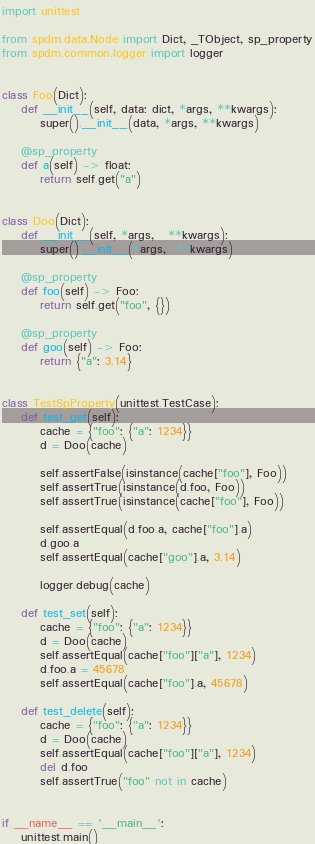<code> <loc_0><loc_0><loc_500><loc_500><_Python_>import unittest

from spdm.data.Node import Dict, _TObject, sp_property
from spdm.common.logger import logger


class Foo(Dict):
    def __init__(self, data: dict, *args, **kwargs):
        super().__init__(data, *args, **kwargs)

    @sp_property
    def a(self) -> float:
        return self.get("a")


class Doo(Dict):
    def __init__(self, *args,   **kwargs):
        super().__init__(*args,  **kwargs)

    @sp_property
    def foo(self) -> Foo:
        return self.get("foo", {})

    @sp_property
    def goo(self) -> Foo:
        return {"a": 3.14}


class TestSpProperty(unittest.TestCase):
    def test_get(self):
        cache = {"foo": {"a": 1234}}
        d = Doo(cache)

        self.assertFalse(isinstance(cache["foo"], Foo))
        self.assertTrue(isinstance(d.foo, Foo))
        self.assertTrue(isinstance(cache["foo"], Foo))

        self.assertEqual(d.foo.a, cache["foo"].a)
        d.goo.a
        self.assertEqual(cache["goo"].a, 3.14)

        logger.debug(cache)

    def test_set(self):
        cache = {"foo": {"a": 1234}}
        d = Doo(cache)
        self.assertEqual(cache["foo"]["a"], 1234)
        d.foo.a = 45678
        self.assertEqual(cache["foo"].a, 45678)

    def test_delete(self):
        cache = {"foo": {"a": 1234}}
        d = Doo(cache)
        self.assertEqual(cache["foo"]["a"], 1234)
        del d.foo
        self.assertTrue("foo" not in cache)


if __name__ == '__main__':
    unittest.main()
</code> 